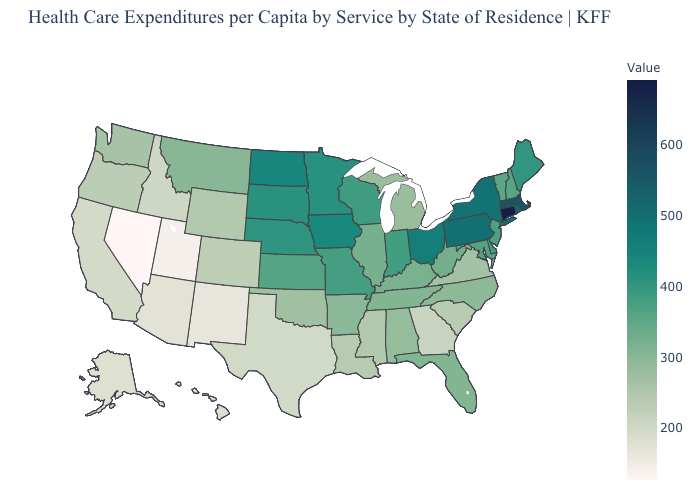Among the states that border Alabama , does Georgia have the lowest value?
Answer briefly. Yes. Among the states that border Missouri , which have the lowest value?
Answer briefly. Oklahoma. 